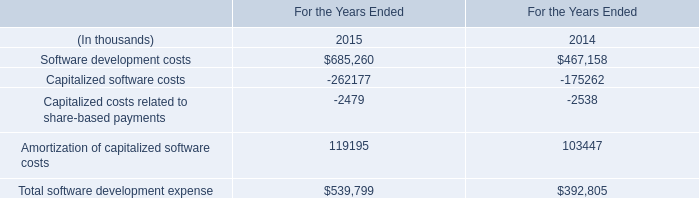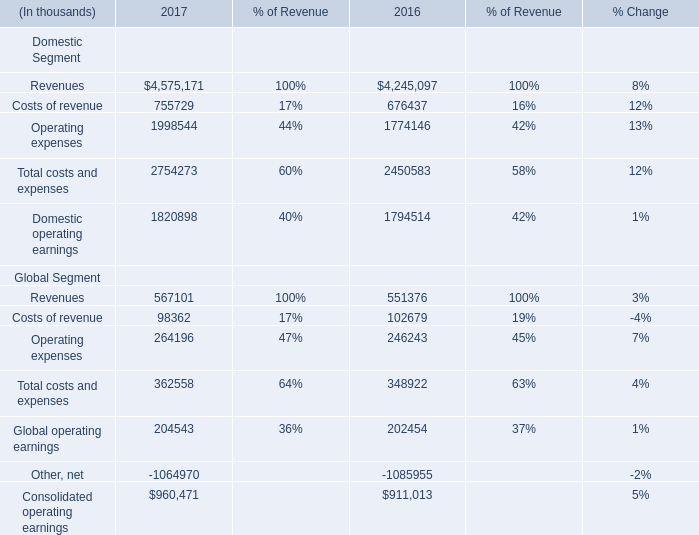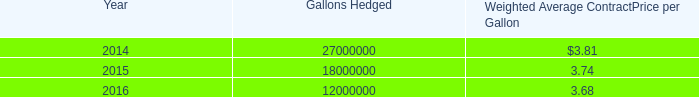What's the average of Other, net Global Segment of 2017, and Software development costs of For the Years Ended 2015 ? 
Computations: ((1064970.0 + 685260.0) / 2)
Answer: 875115.0. 